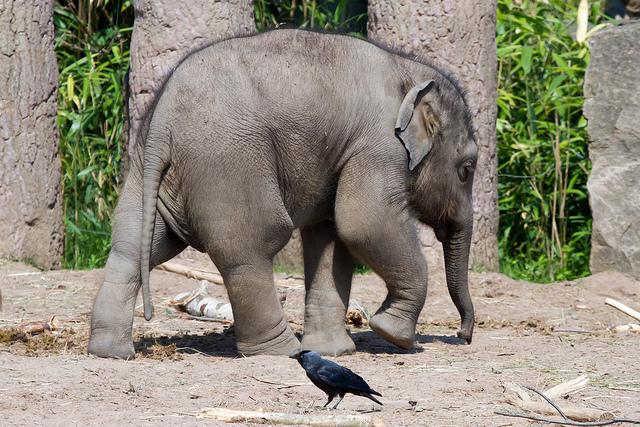How many animals are there?
Be succinct. 2. Is this a young elephant?
Concise answer only. Yes. Is the elephant an adult?
Quick response, please. No. Are there leaves on the nearby tree?
Short answer required. Yes. What color is that bird?
Keep it brief. Black. 